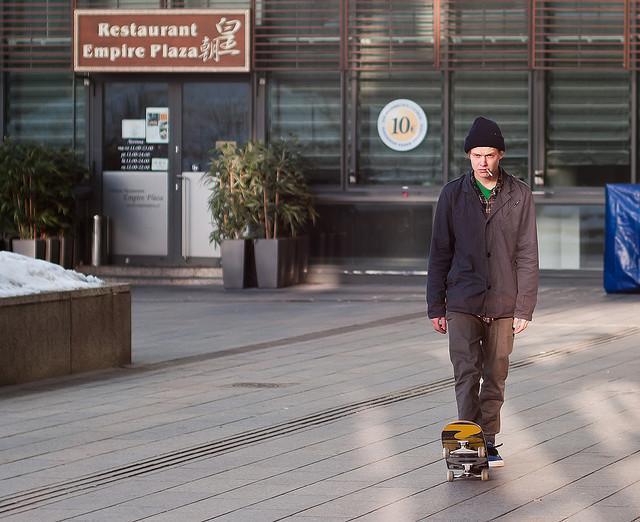How many skateboards can be seen?
Give a very brief answer. 1. How many potted plants are in the photo?
Give a very brief answer. 2. 